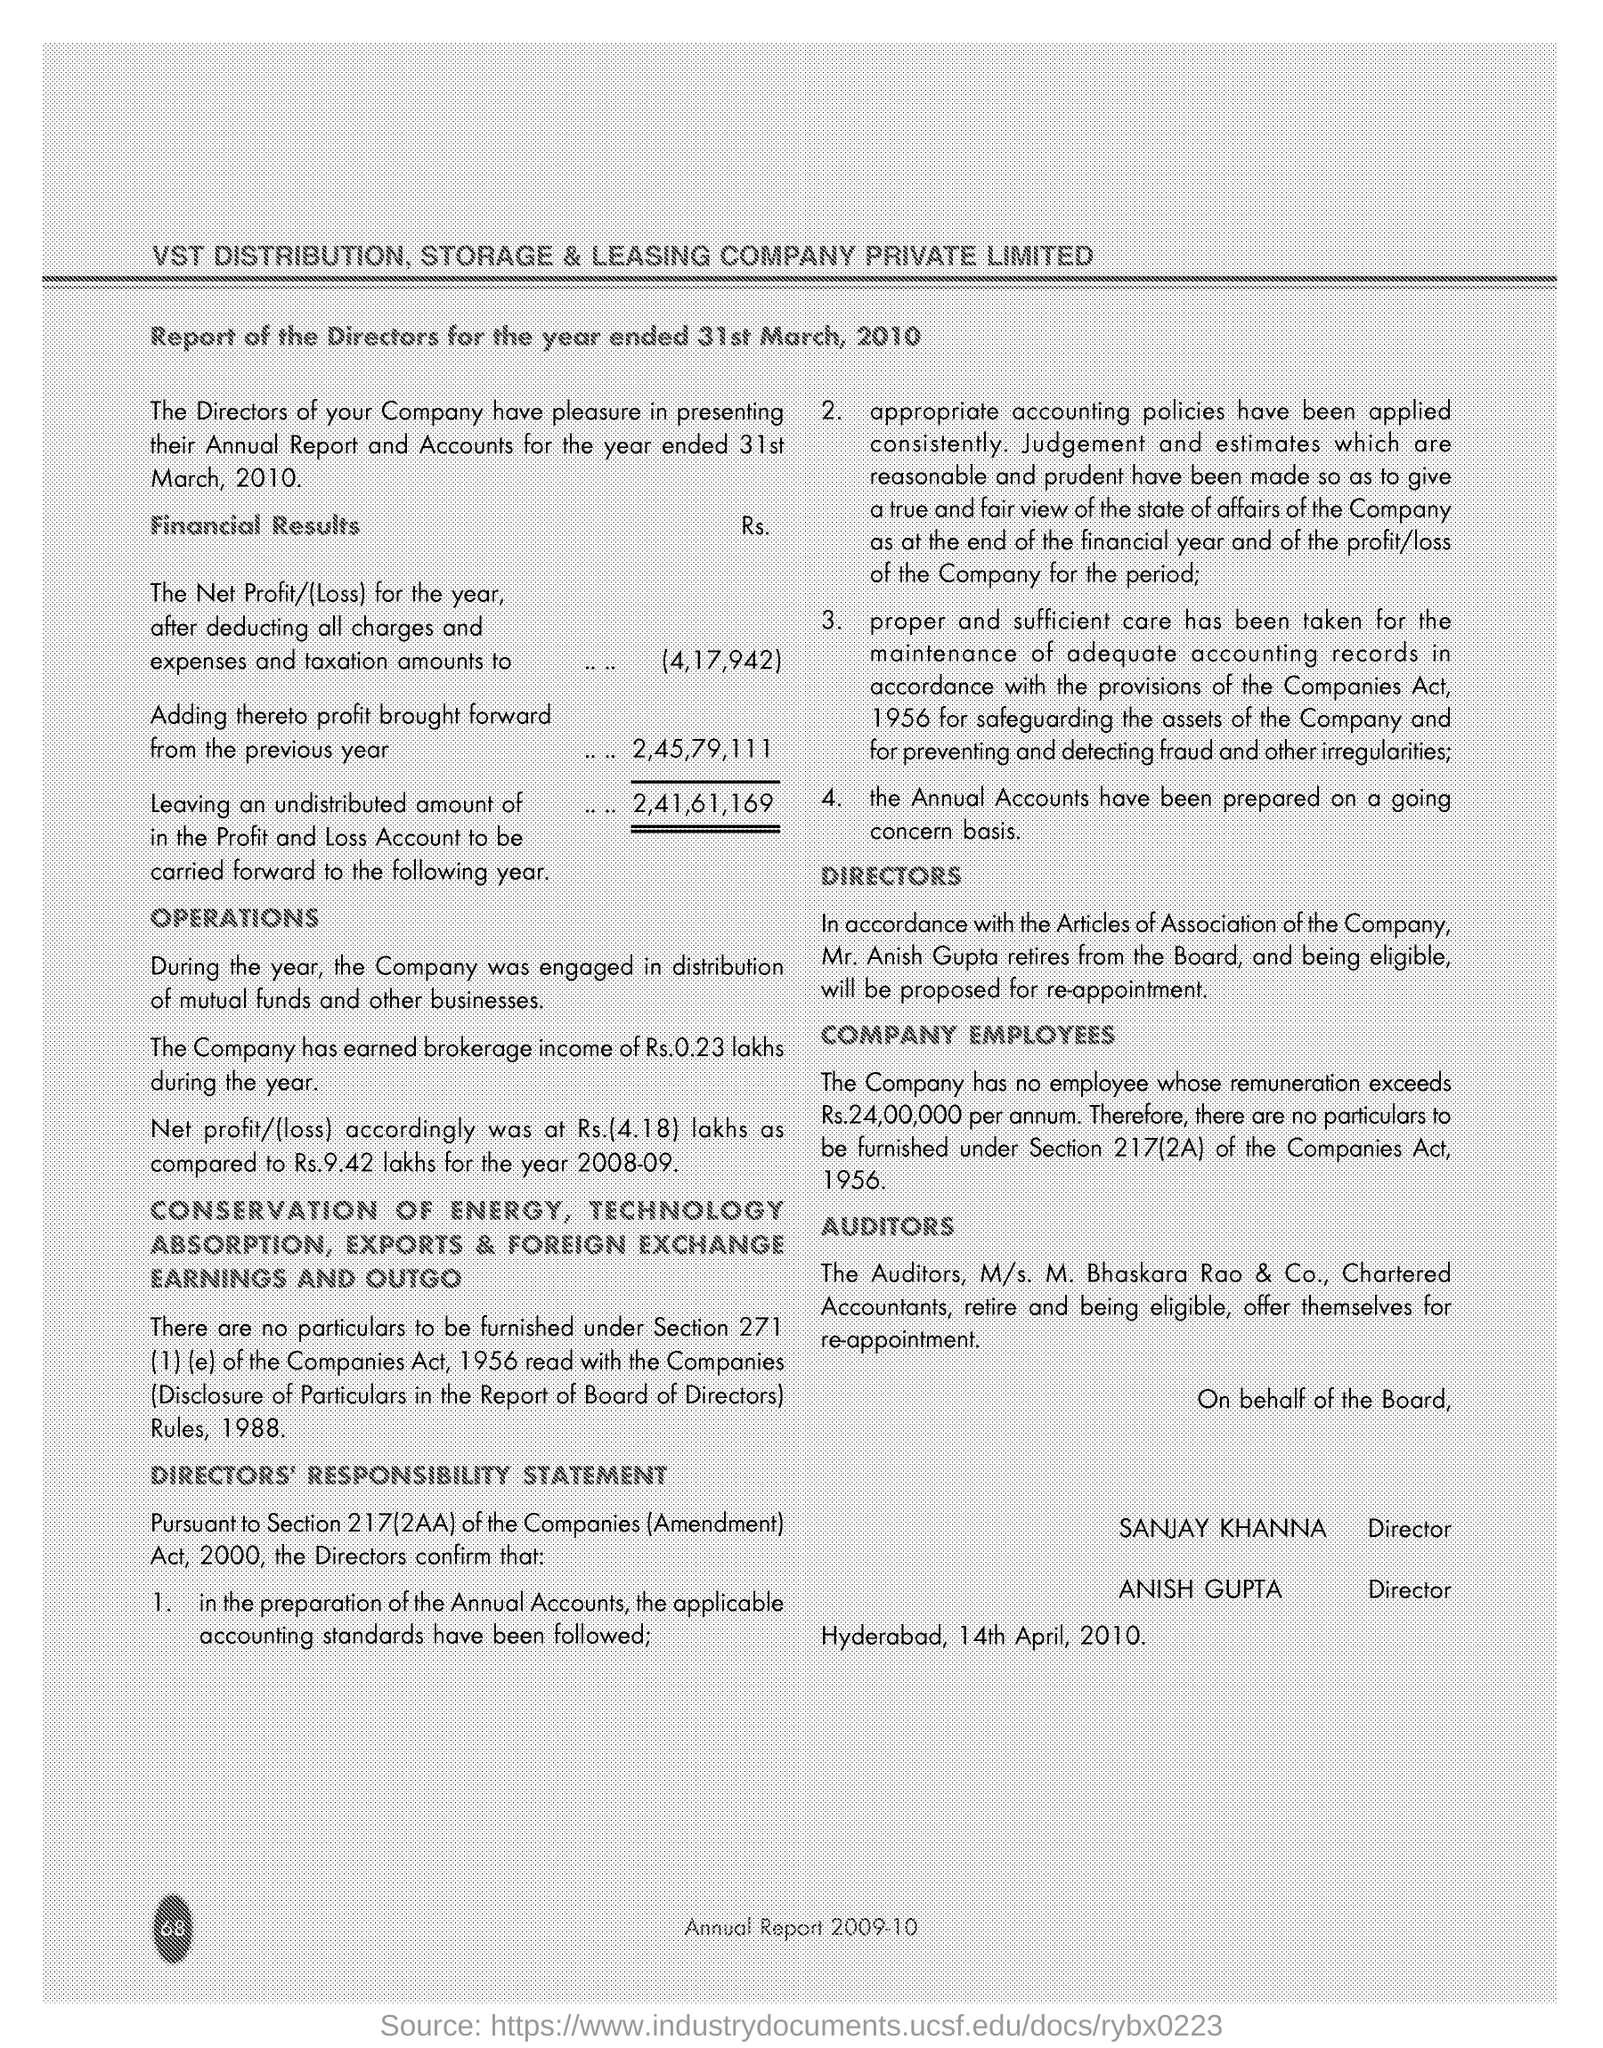What is the Net profit/(Loss)(in Rs.) for the year after deducting all charges and expenses and taxation?
Make the answer very short. (4,17,942). What is the designation of Anish Gupta?
Give a very brief answer. Director. 